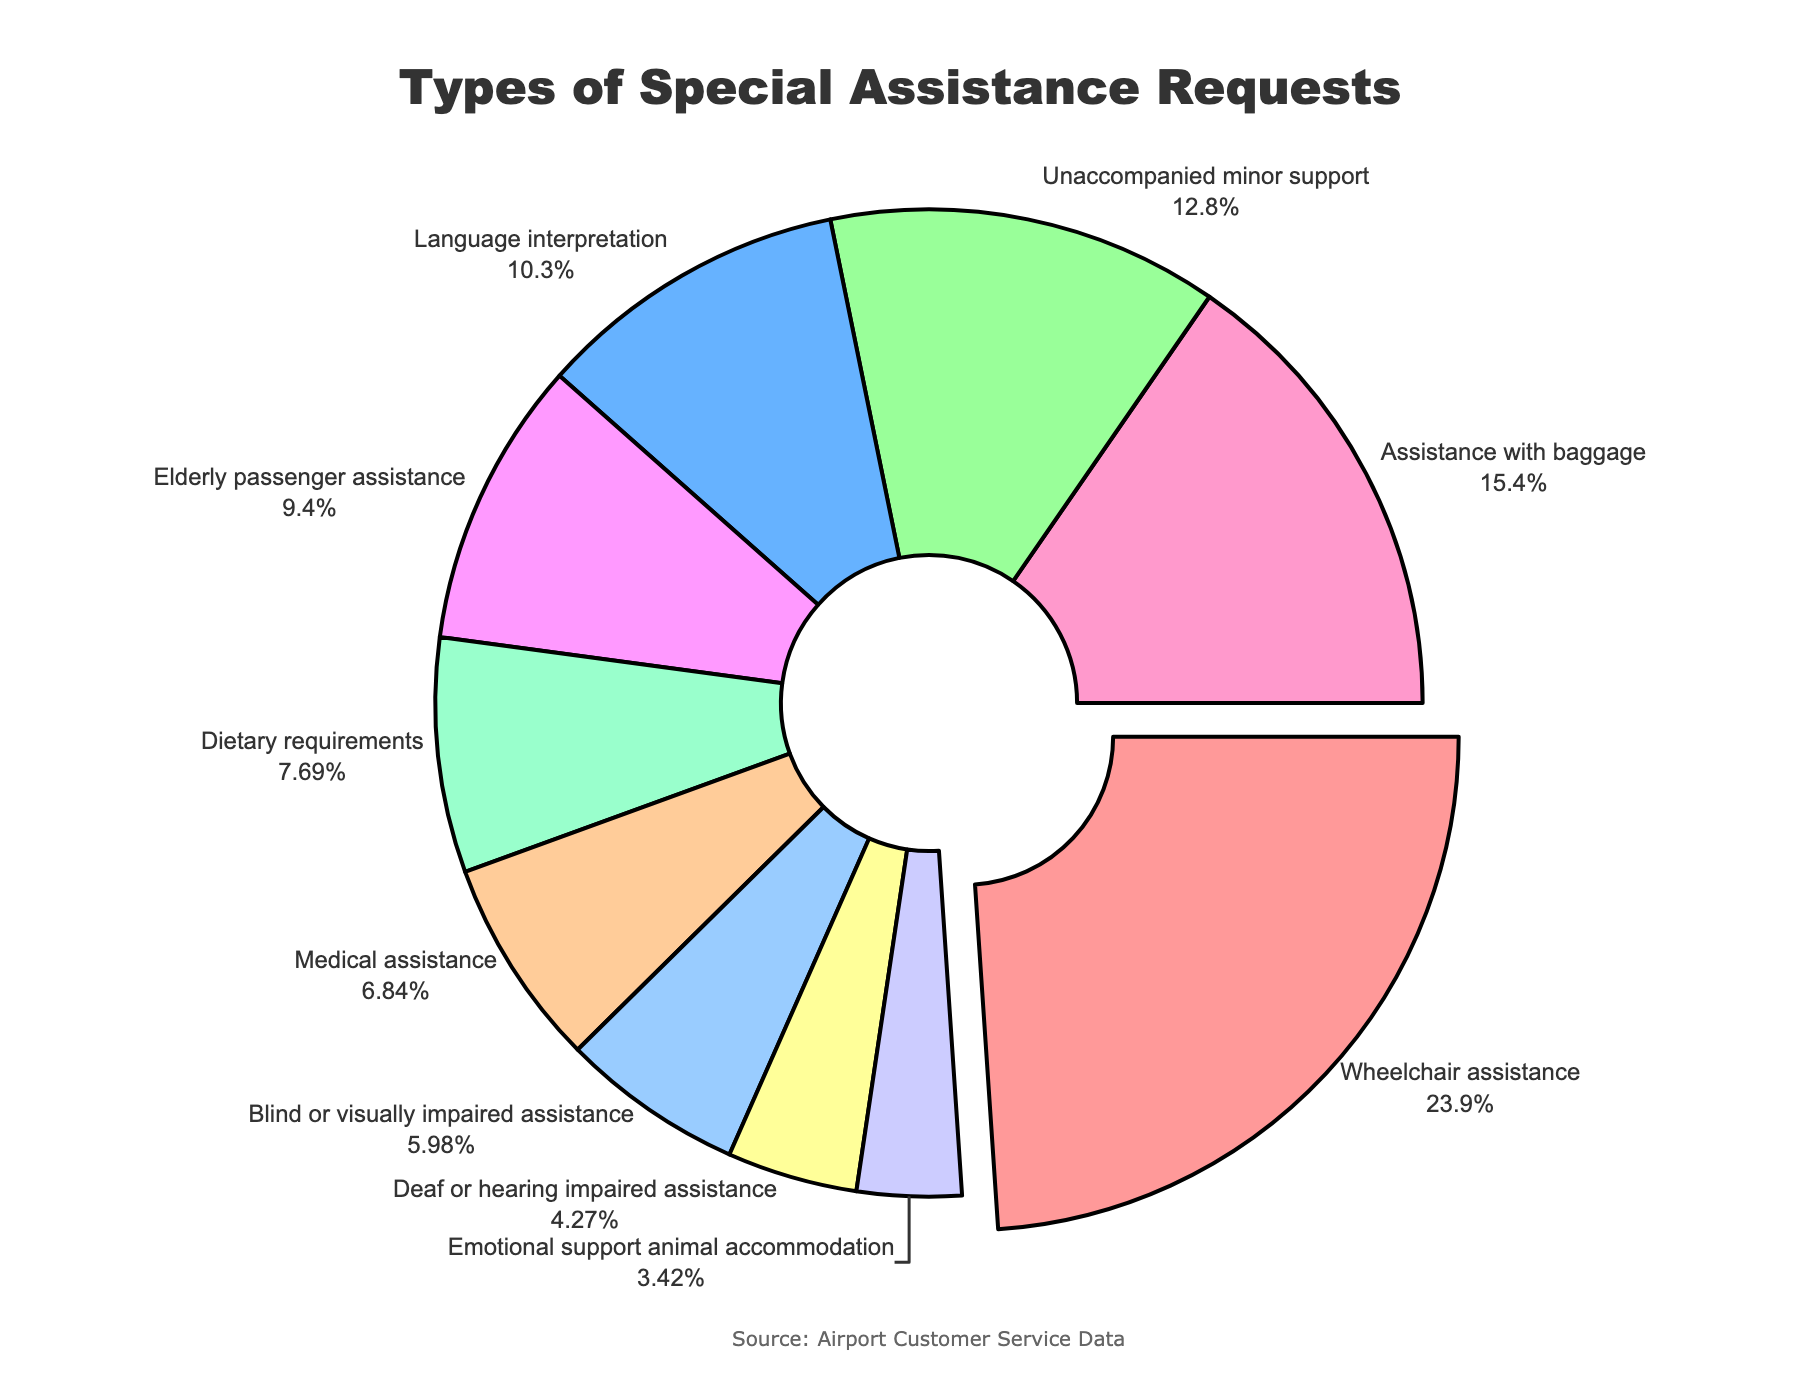Which category has the highest percentage of special assistance requests? By examining the pie chart, the segment representing "Wheelchair assistance" is the largest and is separated slightly from the others, indicating it has the highest percentage.
Answer: Wheelchair assistance Which two categories together make up more than 40% of the requests? The percentages for "Wheelchair assistance" and "Assistance with baggage" are 28% and 18%, respectively. Summing these gives 28 + 18 = 46%, which is more than 40%.
Answer: Wheelchair assistance and Assistance with baggage Which category has the lowest percentage of requests, and what is that percentage? By looking at the pie chart, the segment for "Emotional support animal accommodation" is the smallest, indicating it has the lowest percentage. The text on the segment indicates 4%.
Answer: Emotional support animal accommodation, 4% How many categories have a percentage of 10% or higher? The categories with 10% or higher are "Wheelchair assistance" (28%), "Language interpretation" (12%), "Unaccompanied minor support" (15%), and "Assistance with baggage" (18%), and "Elderly passenger assistance" (11%). Counting these gives 5 categories.
Answer: 5 What is the combined percentage of categories related to medical and dietary needs? The "Medical assistance" segment accounts for 8%, and the "Dietary requirements" segment accounts for 9%. Summing these gives 8 + 9 = 17%.
Answer: 17% How does the percentage for "Language interpretation" compare to "Elderly passenger assistance"? The pie chart shows "Language interpretation" has a percentage of 12%, while "Elderly passenger assistance" has 11%. Comparing these values, 12% is greater than 11%.
Answer: "Language interpretation" > "Elderly passenger assistance" Which color represents "Assistance with baggage" and what percentage does it occupy? In the pie chart, "Assistance with baggage" is represented by an orange-like color, and the corresponding text shows it occupies 18% of the requests.
Answer: Orange-like color, 18% Are there more requests for "Blind or visually impaired assistance" or "Deaf or hearing impaired assistance"? By comparing the pie chart sections, "Blind or visually impaired assistance" has 7%, while "Deaf or hearing impaired assistance" has 5%, so there are more requests for the former.
Answer: Blind or visually impaired assistance What is the total percentage of requests for assistance related to mobility issues? The relevant categories are "Wheelchair assistance" (28%) and "Elderly passenger assistance" (11%). Adding these gives 28 + 11 = 39%.
Answer: 39% How does the need for "Unaccompanied minor support" compare in size to "Dietary requirements" on the chart? The "Unaccompanied minor support" segment, which is 15%, visually appears larger than the "Dietary requirements" segment, which is 9%, as shown in the pie chart.
Answer: "Unaccompanied minor support" > "Dietary requirements" 